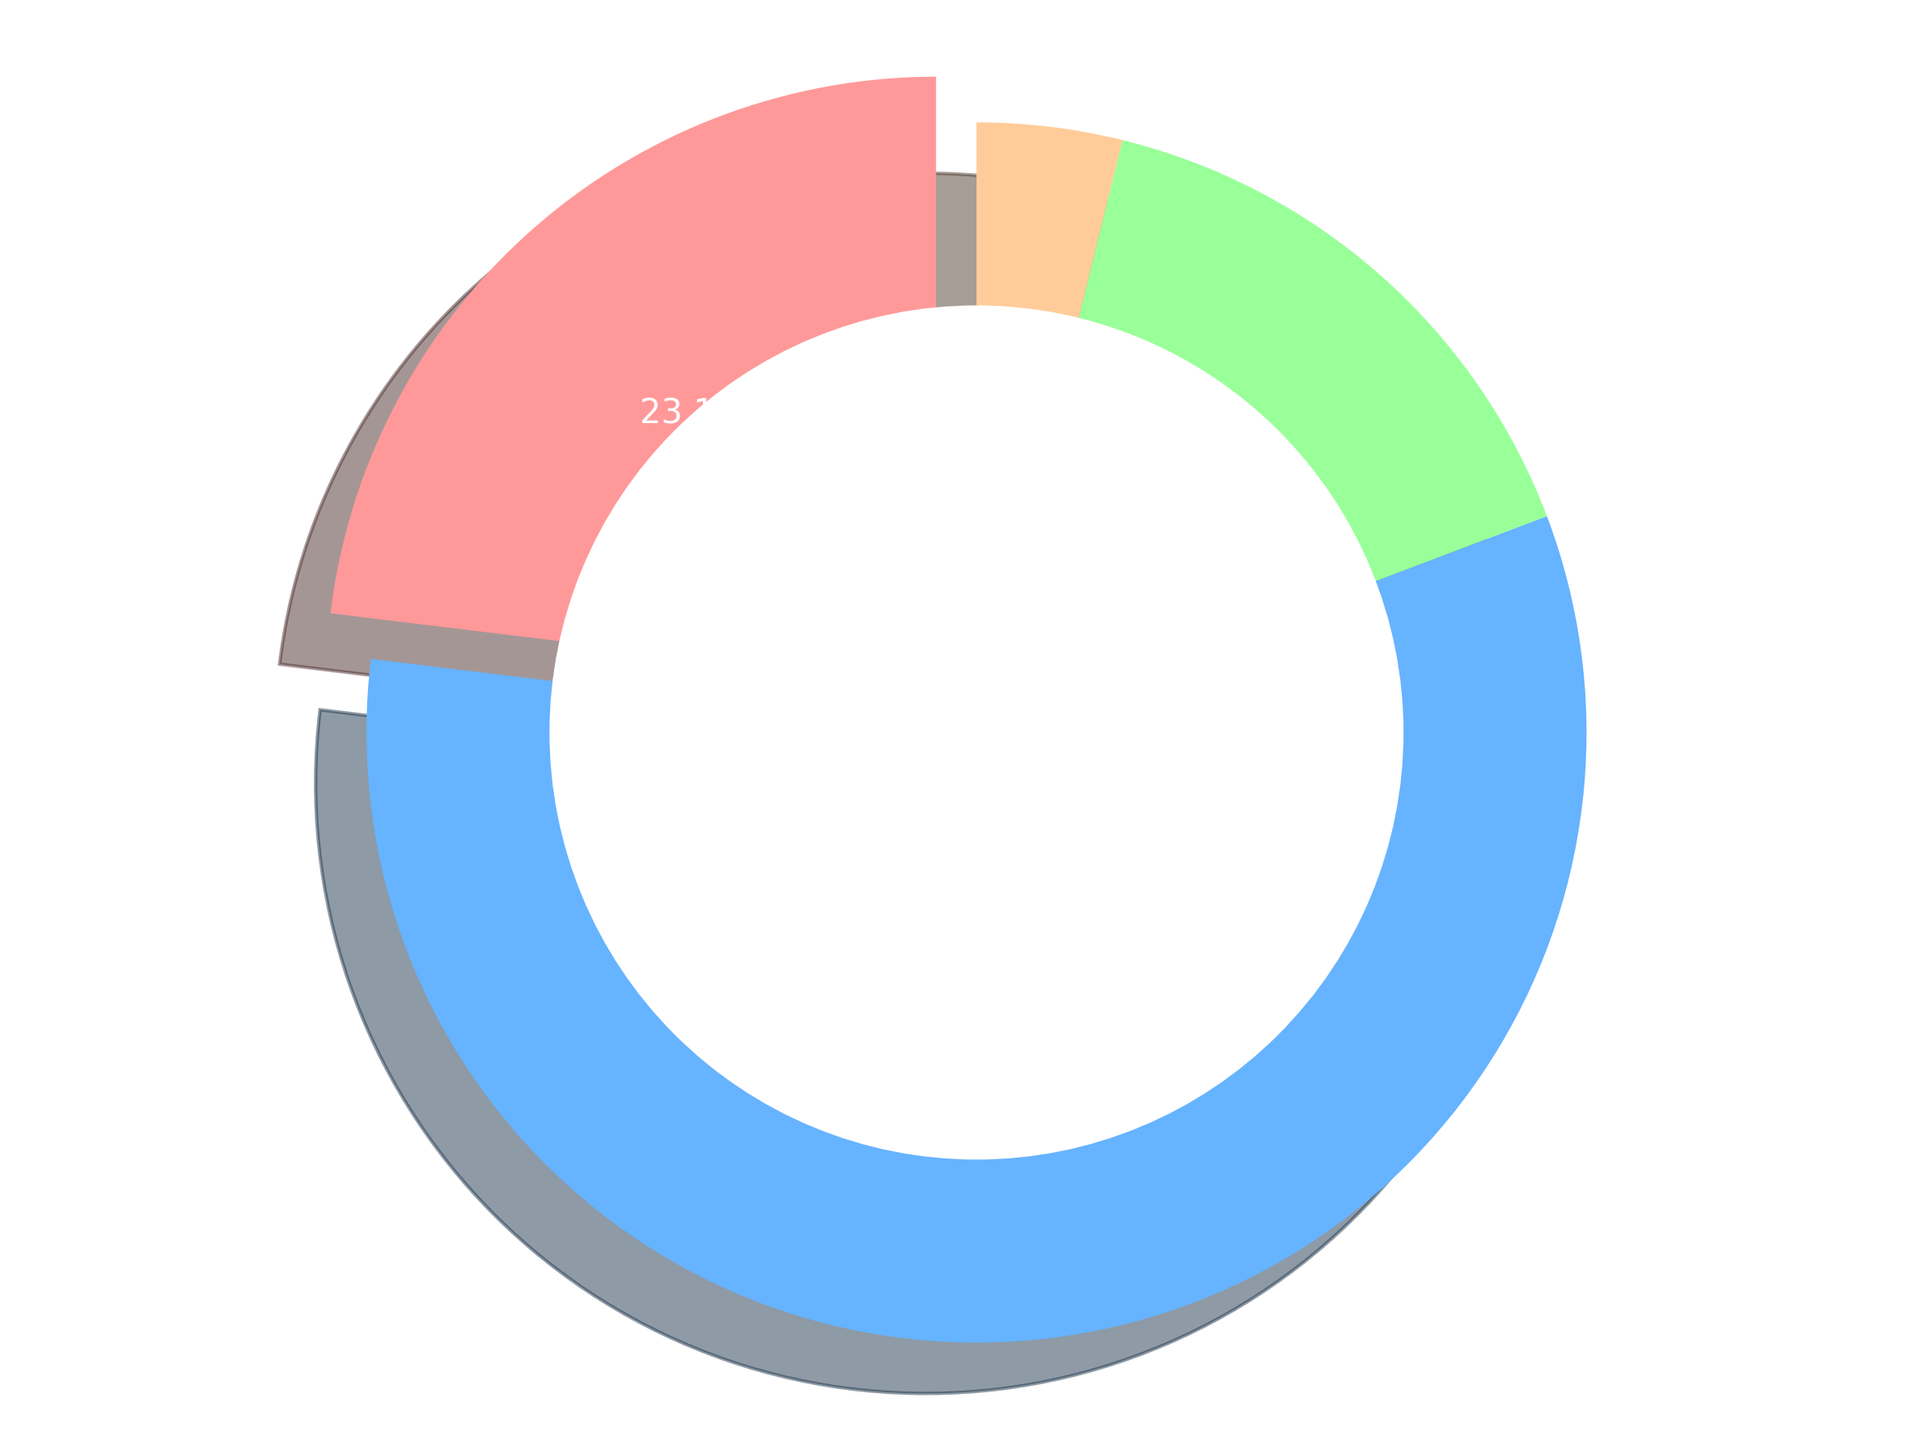How many bookings are there in total for the year? The total number of bookings can be found by summing the bookings for all seasons: Spring (1200) + Summer (3000) + Fall (800) + Winter (200) = 5200.
Answer: 5200 Which season has the highest number of bookings? By looking at the pie chart, the wedge with the largest size represents Summer, which has the highest number of bookings at 3000.
Answer: Summer What percentage of the total bookings does Winter account for? To calculate the percentage of Winter's bookings, divide the Winter bookings by the total bookings and multiply by 100: (200 / 5200) * 100 = 3.8%.
Answer: 3.8% How many more bookings are made in Summer compared to Fall? Subtract the number of Fall bookings from the number of Summer bookings: 3000 - 800 = 2200.
Answer: 2200 What is the combined percentage of bookings for Spring and Fall? First, sum the Spring and Fall bookings: 1200 + 800 = 2000. Then, calculate the percentage of the total by (2000 / 5200) * 100 = 38.5%.
Answer: 38.5% Which season has the smallest proportion of bookings and what is the percentage? The smallest wedge in the pie chart represents Winter, which has 200 bookings. The percentage is (200 / 5200) * 100 = 3.8%.
Answer: Winter, 3.8% How much larger is the proportion of Summer bookings compared to Spring bookings? Calculate the difference in percentage between Summer and Spring. Summer accounts for (3000 / 5200) * 100 = 57.7%, while Spring accounts for (1200 / 5200) * 100 = 23.1%. The difference is 57.7% - 23.1% = 34.6%.
Answer: 34.6% How does the number of Spring bookings compare to the number of Fall bookings? Compare the number of bookings directly: Spring has 1200 bookings and Fall has 800. Spring has 1200 - 800 = 400 more bookings than Fall.
Answer: Spring has 400 more bookings than Fall Describe the visual attributes of the pie chart that emphasize the season with the highest bookings. The season with the highest bookings, Summer, is visually emphasized by a larger slice and different position (starting from the top). Additionally, the slice is not "exploded" like the Spring slice, yet it clearly stands out due to its size.
Answer: Large slice, top position What is the ratio of Summer bookings to Winter bookings? Divide the number of Summer bookings by the number of Winter bookings: 3000 / 200 = 15.
Answer: 15 